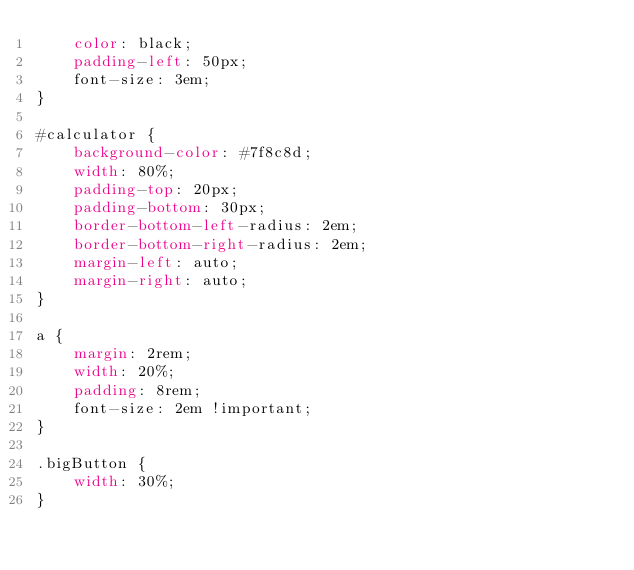Convert code to text. <code><loc_0><loc_0><loc_500><loc_500><_CSS_>    color: black;
    padding-left: 50px;
    font-size: 3em;
}

#calculator {
    background-color: #7f8c8d;
    width: 80%;
    padding-top: 20px;
    padding-bottom: 30px;
    border-bottom-left-radius: 2em;
    border-bottom-right-radius: 2em;
    margin-left: auto;
    margin-right: auto;
}

a {
    margin: 2rem;
    width: 20%;
    padding: 8rem;
    font-size: 2em !important;
}

.bigButton {
    width: 30%;
}
</code> 